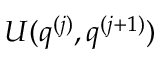Convert formula to latex. <formula><loc_0><loc_0><loc_500><loc_500>U ( q ^ { ( j ) } , q ^ { ( j + 1 ) } )</formula> 